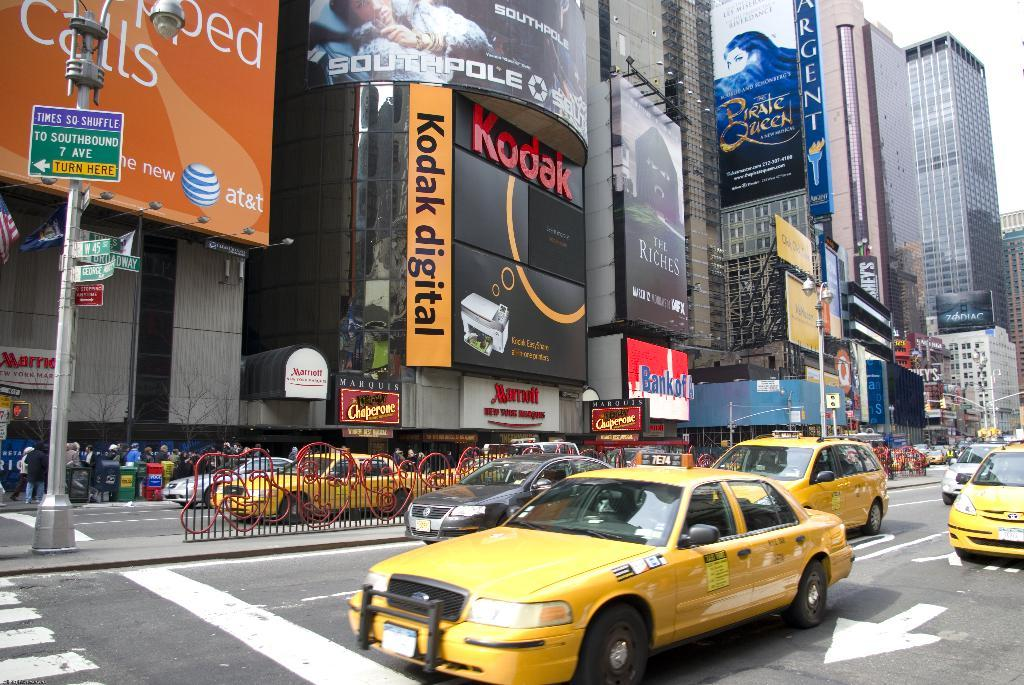<image>
Present a compact description of the photo's key features. A Kodak digital sign can be seen on a building in a city. 